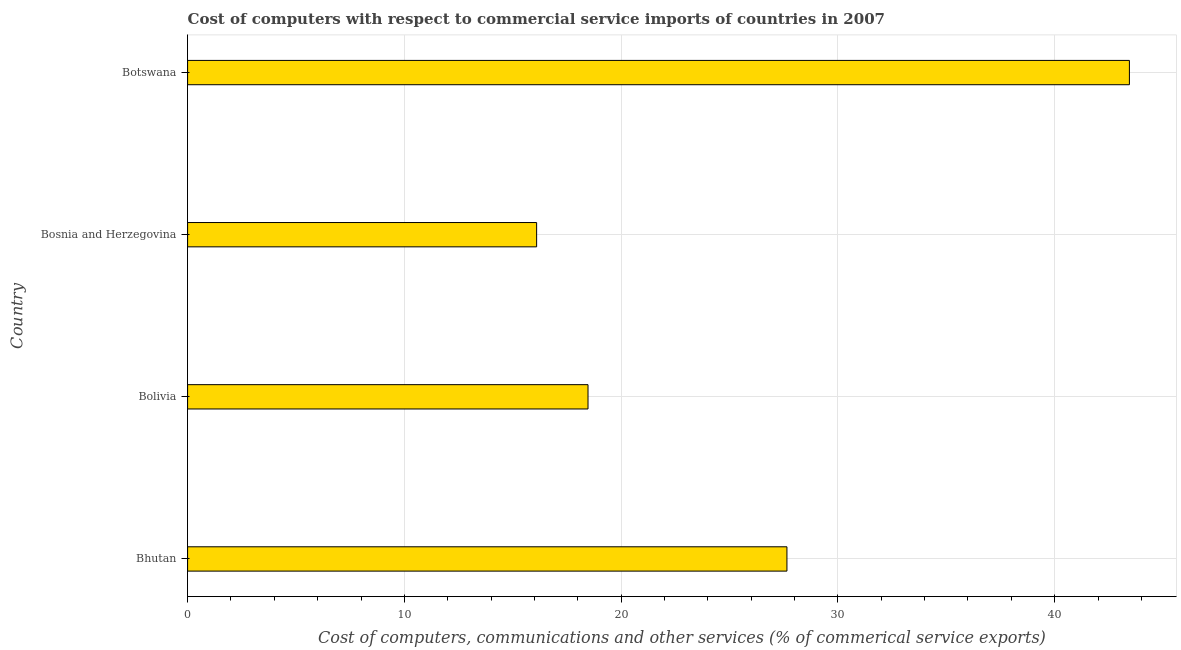Does the graph contain grids?
Your answer should be compact. Yes. What is the title of the graph?
Make the answer very short. Cost of computers with respect to commercial service imports of countries in 2007. What is the label or title of the X-axis?
Make the answer very short. Cost of computers, communications and other services (% of commerical service exports). What is the  computer and other services in Bosnia and Herzegovina?
Offer a terse response. 16.1. Across all countries, what is the maximum cost of communications?
Offer a very short reply. 43.45. Across all countries, what is the minimum  computer and other services?
Make the answer very short. 16.1. In which country was the cost of communications maximum?
Make the answer very short. Botswana. In which country was the  computer and other services minimum?
Make the answer very short. Bosnia and Herzegovina. What is the sum of the cost of communications?
Make the answer very short. 105.67. What is the difference between the  computer and other services in Bolivia and Botswana?
Offer a terse response. -24.98. What is the average cost of communications per country?
Provide a succinct answer. 26.42. What is the median  computer and other services?
Your answer should be compact. 23.06. What is the ratio of the  computer and other services in Bolivia to that in Bosnia and Herzegovina?
Make the answer very short. 1.15. Is the cost of communications in Bosnia and Herzegovina less than that in Botswana?
Offer a very short reply. Yes. Is the difference between the  computer and other services in Bhutan and Bolivia greater than the difference between any two countries?
Provide a short and direct response. No. What is the difference between the highest and the second highest  computer and other services?
Your answer should be very brief. 15.8. What is the difference between the highest and the lowest cost of communications?
Your response must be concise. 27.35. In how many countries, is the  computer and other services greater than the average  computer and other services taken over all countries?
Provide a short and direct response. 2. How many bars are there?
Offer a terse response. 4. How many countries are there in the graph?
Your answer should be very brief. 4. What is the Cost of computers, communications and other services (% of commerical service exports) of Bhutan?
Provide a short and direct response. 27.65. What is the Cost of computers, communications and other services (% of commerical service exports) of Bolivia?
Provide a succinct answer. 18.47. What is the Cost of computers, communications and other services (% of commerical service exports) in Bosnia and Herzegovina?
Keep it short and to the point. 16.1. What is the Cost of computers, communications and other services (% of commerical service exports) in Botswana?
Keep it short and to the point. 43.45. What is the difference between the Cost of computers, communications and other services (% of commerical service exports) in Bhutan and Bolivia?
Offer a terse response. 9.18. What is the difference between the Cost of computers, communications and other services (% of commerical service exports) in Bhutan and Bosnia and Herzegovina?
Ensure brevity in your answer.  11.55. What is the difference between the Cost of computers, communications and other services (% of commerical service exports) in Bhutan and Botswana?
Provide a succinct answer. -15.8. What is the difference between the Cost of computers, communications and other services (% of commerical service exports) in Bolivia and Bosnia and Herzegovina?
Your answer should be very brief. 2.37. What is the difference between the Cost of computers, communications and other services (% of commerical service exports) in Bolivia and Botswana?
Ensure brevity in your answer.  -24.97. What is the difference between the Cost of computers, communications and other services (% of commerical service exports) in Bosnia and Herzegovina and Botswana?
Your answer should be compact. -27.35. What is the ratio of the Cost of computers, communications and other services (% of commerical service exports) in Bhutan to that in Bolivia?
Your answer should be compact. 1.5. What is the ratio of the Cost of computers, communications and other services (% of commerical service exports) in Bhutan to that in Bosnia and Herzegovina?
Ensure brevity in your answer.  1.72. What is the ratio of the Cost of computers, communications and other services (% of commerical service exports) in Bhutan to that in Botswana?
Offer a very short reply. 0.64. What is the ratio of the Cost of computers, communications and other services (% of commerical service exports) in Bolivia to that in Bosnia and Herzegovina?
Your answer should be very brief. 1.15. What is the ratio of the Cost of computers, communications and other services (% of commerical service exports) in Bolivia to that in Botswana?
Offer a very short reply. 0.42. What is the ratio of the Cost of computers, communications and other services (% of commerical service exports) in Bosnia and Herzegovina to that in Botswana?
Provide a succinct answer. 0.37. 